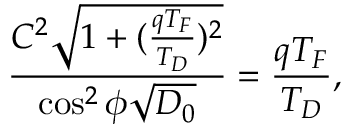<formula> <loc_0><loc_0><loc_500><loc_500>\frac { C ^ { 2 } \sqrt { 1 + ( \frac { q T _ { F } } { T _ { D } } ) ^ { 2 } } } { \cos ^ { 2 } \phi \sqrt { D _ { 0 } } } = \frac { q T _ { F } } { T _ { D } } ,</formula> 